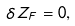Convert formula to latex. <formula><loc_0><loc_0><loc_500><loc_500>\delta Z _ { F } = 0 ,</formula> 